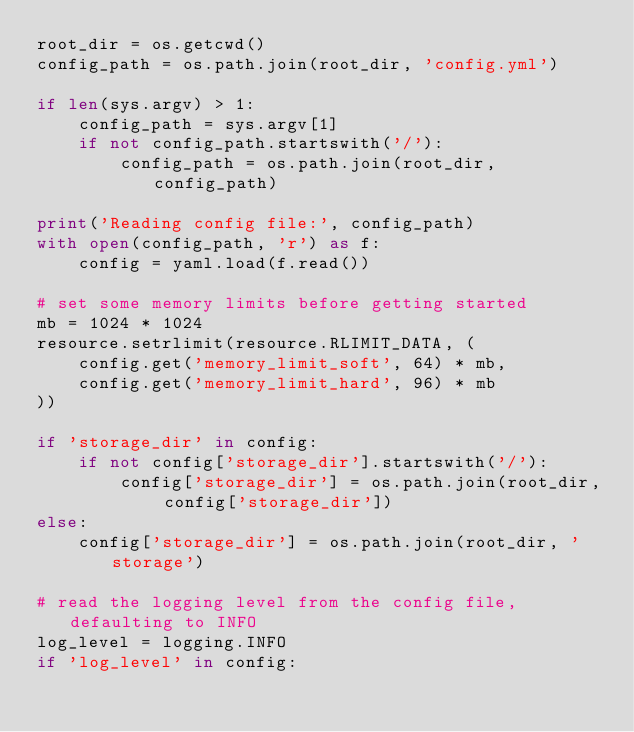Convert code to text. <code><loc_0><loc_0><loc_500><loc_500><_Python_>root_dir = os.getcwd()
config_path = os.path.join(root_dir, 'config.yml')

if len(sys.argv) > 1:
	config_path = sys.argv[1]
	if not config_path.startswith('/'):
		config_path = os.path.join(root_dir, config_path)

print('Reading config file:', config_path)
with open(config_path, 'r') as f:
	config = yaml.load(f.read())

# set some memory limits before getting started
mb = 1024 * 1024
resource.setrlimit(resource.RLIMIT_DATA, (
	config.get('memory_limit_soft', 64) * mb,
	config.get('memory_limit_hard', 96) * mb
))

if 'storage_dir' in config:
	if not config['storage_dir'].startswith('/'):
		config['storage_dir'] = os.path.join(root_dir, config['storage_dir'])
else:
	config['storage_dir'] = os.path.join(root_dir, 'storage')

# read the logging level from the config file, defaulting to INFO
log_level = logging.INFO
if 'log_level' in config:</code> 